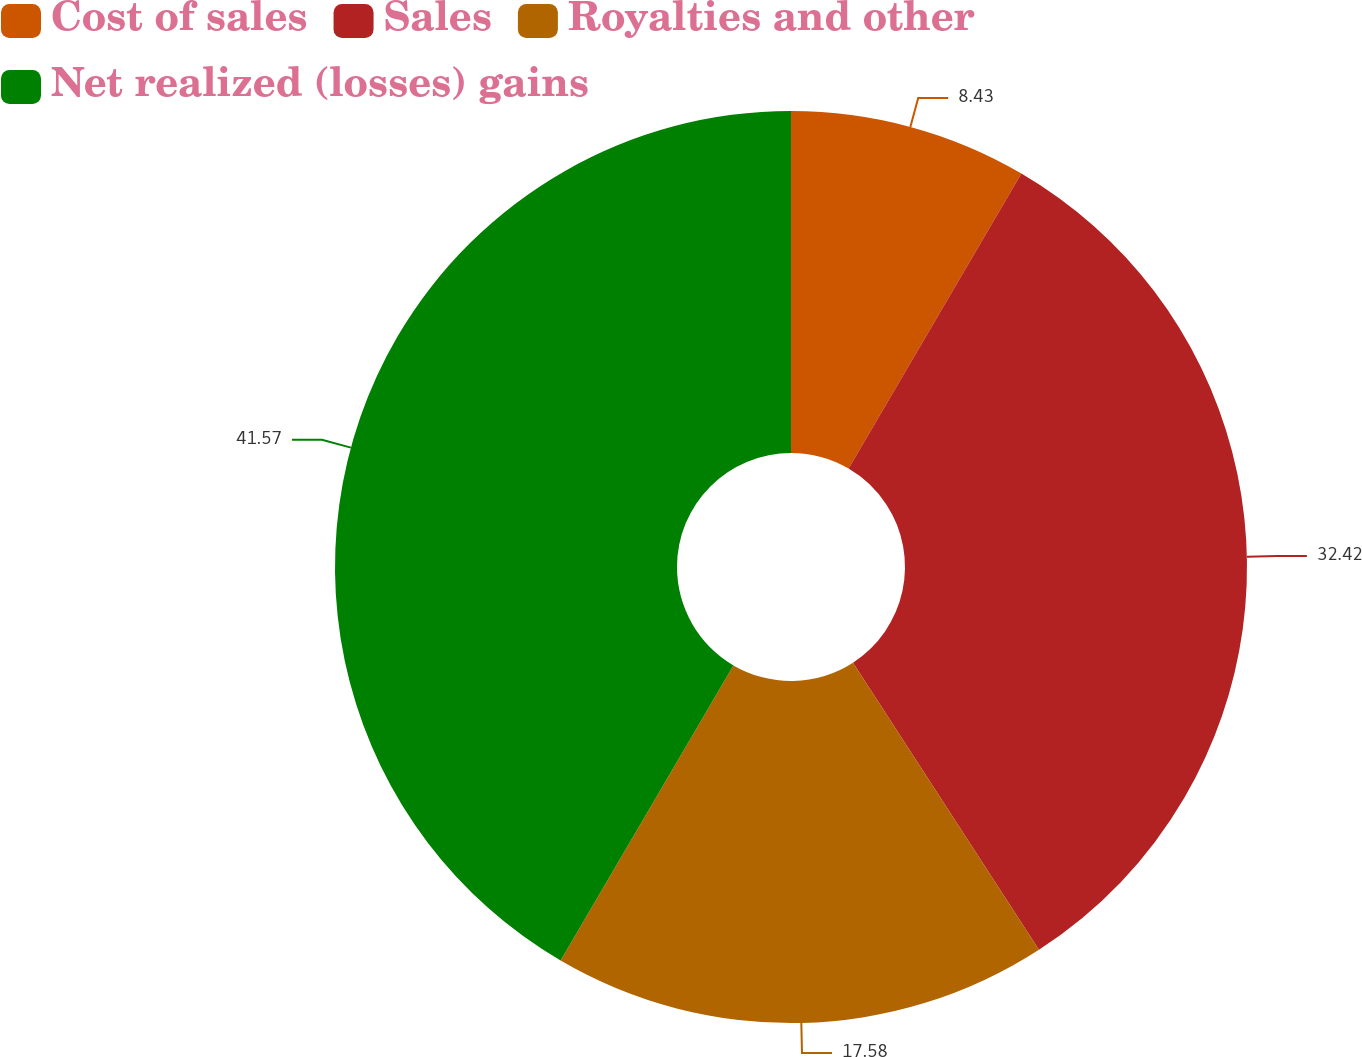<chart> <loc_0><loc_0><loc_500><loc_500><pie_chart><fcel>Cost of sales<fcel>Sales<fcel>Royalties and other<fcel>Net realized (losses) gains<nl><fcel>8.43%<fcel>32.42%<fcel>17.58%<fcel>41.57%<nl></chart> 